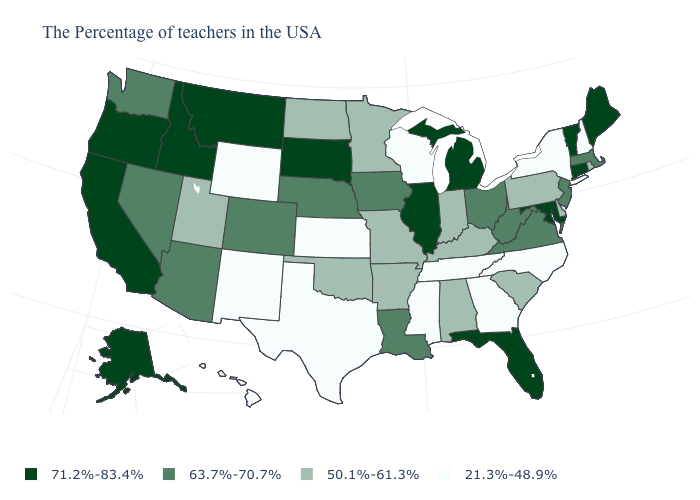What is the value of Mississippi?
Concise answer only. 21.3%-48.9%. What is the value of Kentucky?
Give a very brief answer. 50.1%-61.3%. Does the map have missing data?
Write a very short answer. No. What is the lowest value in the MidWest?
Be succinct. 21.3%-48.9%. What is the value of Minnesota?
Answer briefly. 50.1%-61.3%. Name the states that have a value in the range 50.1%-61.3%?
Answer briefly. Rhode Island, Delaware, Pennsylvania, South Carolina, Kentucky, Indiana, Alabama, Missouri, Arkansas, Minnesota, Oklahoma, North Dakota, Utah. Name the states that have a value in the range 63.7%-70.7%?
Give a very brief answer. Massachusetts, New Jersey, Virginia, West Virginia, Ohio, Louisiana, Iowa, Nebraska, Colorado, Arizona, Nevada, Washington. How many symbols are there in the legend?
Answer briefly. 4. What is the value of Nevada?
Be succinct. 63.7%-70.7%. Name the states that have a value in the range 71.2%-83.4%?
Write a very short answer. Maine, Vermont, Connecticut, Maryland, Florida, Michigan, Illinois, South Dakota, Montana, Idaho, California, Oregon, Alaska. Which states have the lowest value in the MidWest?
Answer briefly. Wisconsin, Kansas. What is the value of Kansas?
Short answer required. 21.3%-48.9%. Name the states that have a value in the range 71.2%-83.4%?
Be succinct. Maine, Vermont, Connecticut, Maryland, Florida, Michigan, Illinois, South Dakota, Montana, Idaho, California, Oregon, Alaska. Does Rhode Island have the lowest value in the USA?
Answer briefly. No. What is the value of North Dakota?
Quick response, please. 50.1%-61.3%. 